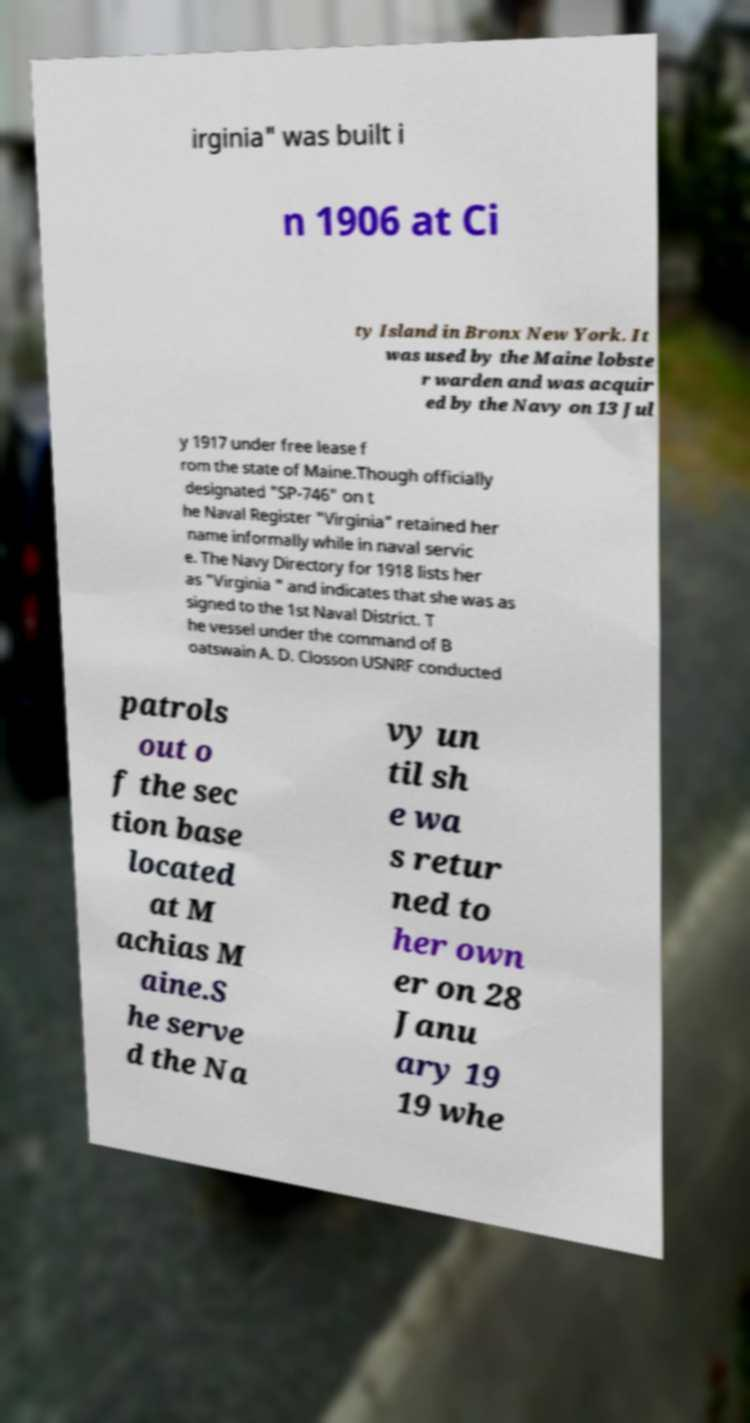Please identify and transcribe the text found in this image. irginia" was built i n 1906 at Ci ty Island in Bronx New York. It was used by the Maine lobste r warden and was acquir ed by the Navy on 13 Jul y 1917 under free lease f rom the state of Maine.Though officially designated "SP-746" on t he Naval Register "Virginia" retained her name informally while in naval servic e. The Navy Directory for 1918 lists her as "Virginia " and indicates that she was as signed to the 1st Naval District. T he vessel under the command of B oatswain A. D. Closson USNRF conducted patrols out o f the sec tion base located at M achias M aine.S he serve d the Na vy un til sh e wa s retur ned to her own er on 28 Janu ary 19 19 whe 